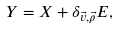Convert formula to latex. <formula><loc_0><loc_0><loc_500><loc_500>Y = X + \delta _ { \vec { v } , \vec { \rho } } E ,</formula> 